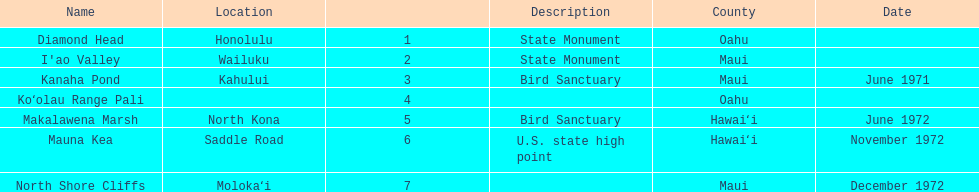How many names do not have a description? 2. 